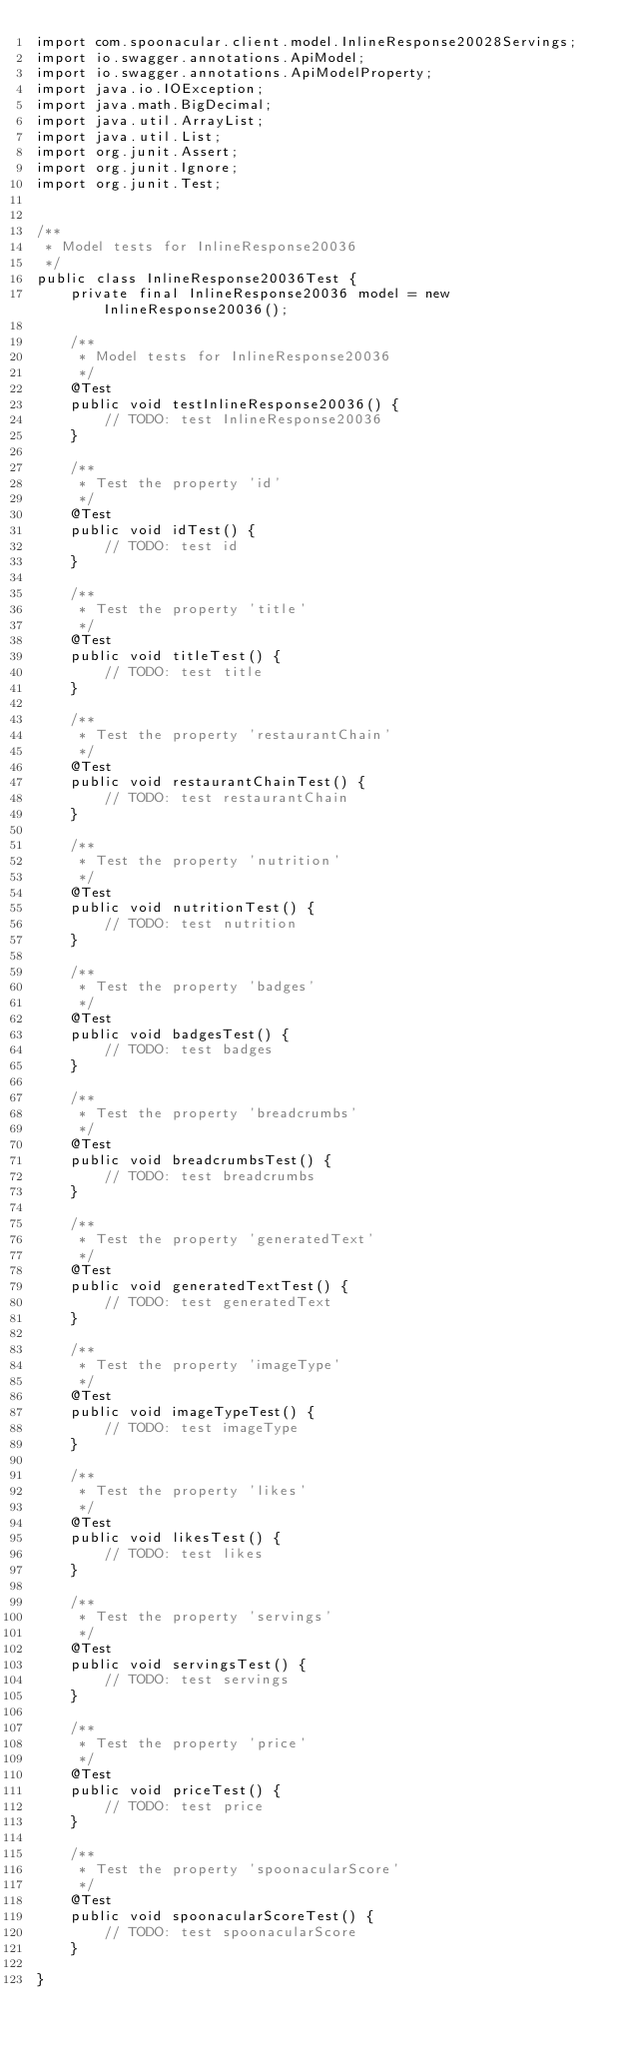Convert code to text. <code><loc_0><loc_0><loc_500><loc_500><_Java_>import com.spoonacular.client.model.InlineResponse20028Servings;
import io.swagger.annotations.ApiModel;
import io.swagger.annotations.ApiModelProperty;
import java.io.IOException;
import java.math.BigDecimal;
import java.util.ArrayList;
import java.util.List;
import org.junit.Assert;
import org.junit.Ignore;
import org.junit.Test;


/**
 * Model tests for InlineResponse20036
 */
public class InlineResponse20036Test {
    private final InlineResponse20036 model = new InlineResponse20036();

    /**
     * Model tests for InlineResponse20036
     */
    @Test
    public void testInlineResponse20036() {
        // TODO: test InlineResponse20036
    }

    /**
     * Test the property 'id'
     */
    @Test
    public void idTest() {
        // TODO: test id
    }

    /**
     * Test the property 'title'
     */
    @Test
    public void titleTest() {
        // TODO: test title
    }

    /**
     * Test the property 'restaurantChain'
     */
    @Test
    public void restaurantChainTest() {
        // TODO: test restaurantChain
    }

    /**
     * Test the property 'nutrition'
     */
    @Test
    public void nutritionTest() {
        // TODO: test nutrition
    }

    /**
     * Test the property 'badges'
     */
    @Test
    public void badgesTest() {
        // TODO: test badges
    }

    /**
     * Test the property 'breadcrumbs'
     */
    @Test
    public void breadcrumbsTest() {
        // TODO: test breadcrumbs
    }

    /**
     * Test the property 'generatedText'
     */
    @Test
    public void generatedTextTest() {
        // TODO: test generatedText
    }

    /**
     * Test the property 'imageType'
     */
    @Test
    public void imageTypeTest() {
        // TODO: test imageType
    }

    /**
     * Test the property 'likes'
     */
    @Test
    public void likesTest() {
        // TODO: test likes
    }

    /**
     * Test the property 'servings'
     */
    @Test
    public void servingsTest() {
        // TODO: test servings
    }

    /**
     * Test the property 'price'
     */
    @Test
    public void priceTest() {
        // TODO: test price
    }

    /**
     * Test the property 'spoonacularScore'
     */
    @Test
    public void spoonacularScoreTest() {
        // TODO: test spoonacularScore
    }

}
</code> 